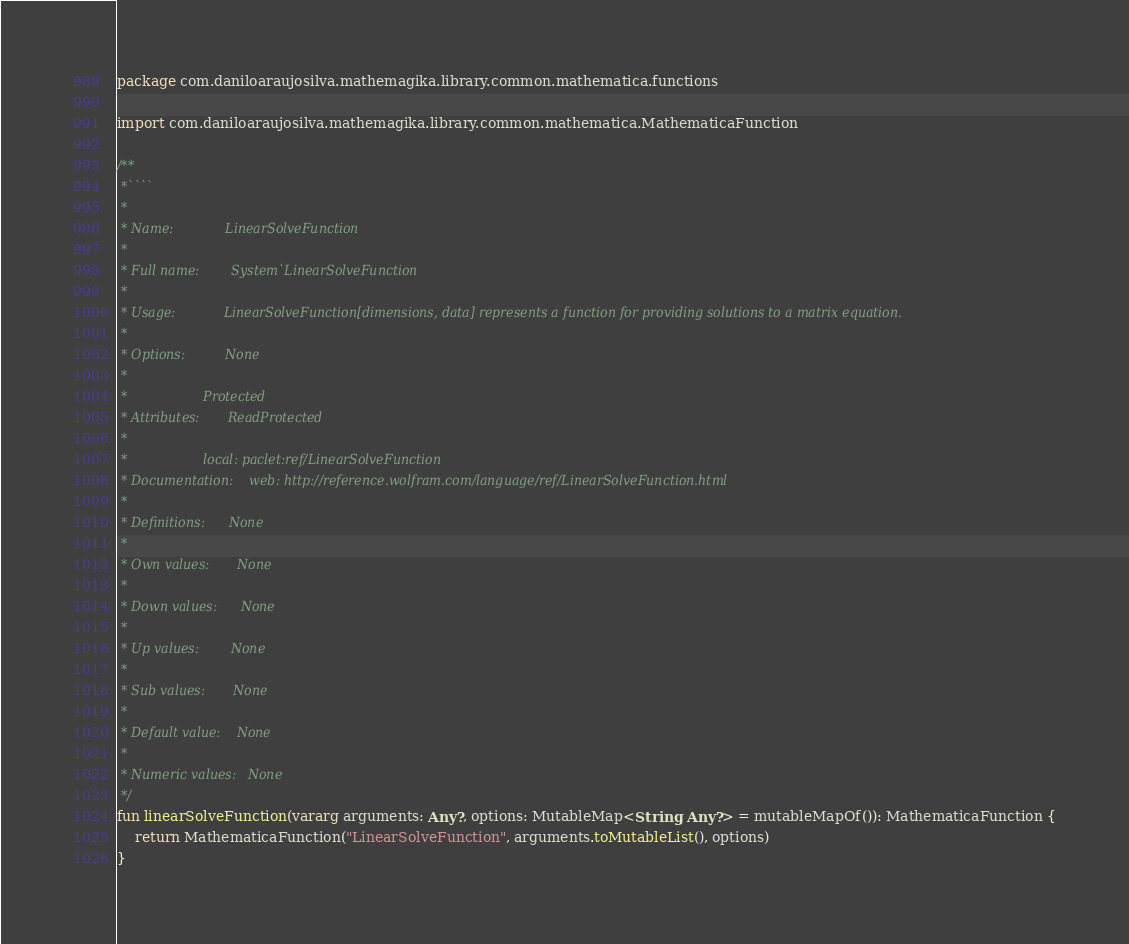<code> <loc_0><loc_0><loc_500><loc_500><_Kotlin_>package com.daniloaraujosilva.mathemagika.library.common.mathematica.functions

import com.daniloaraujosilva.mathemagika.library.common.mathematica.MathematicaFunction

/**
 *````
 *
 * Name:             LinearSolveFunction
 *
 * Full name:        System`LinearSolveFunction
 *
 * Usage:            LinearSolveFunction[dimensions, data] represents a function for providing solutions to a matrix equation.
 *
 * Options:          None
 *
 *                   Protected
 * Attributes:       ReadProtected
 *
 *                   local: paclet:ref/LinearSolveFunction
 * Documentation:    web: http://reference.wolfram.com/language/ref/LinearSolveFunction.html
 *
 * Definitions:      None
 *
 * Own values:       None
 *
 * Down values:      None
 *
 * Up values:        None
 *
 * Sub values:       None
 *
 * Default value:    None
 *
 * Numeric values:   None
 */
fun linearSolveFunction(vararg arguments: Any?, options: MutableMap<String, Any?> = mutableMapOf()): MathematicaFunction {
	return MathematicaFunction("LinearSolveFunction", arguments.toMutableList(), options)
}
</code> 